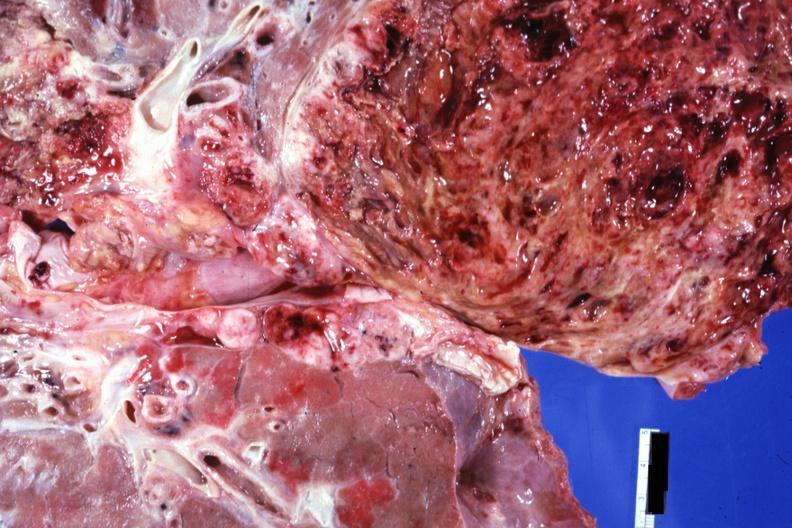what is close-up view of tumor cut?
Answer the question using a single word or phrase. Tumor cut surface 